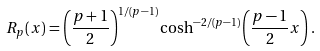<formula> <loc_0><loc_0><loc_500><loc_500>R _ { p } ( x ) = \left ( \frac { p + 1 } { 2 } \right ) ^ { 1 / ( p - 1 ) } \cosh ^ { - 2 / ( p - 1 ) } \left ( \frac { p - 1 } { 2 } x \right ) .</formula> 